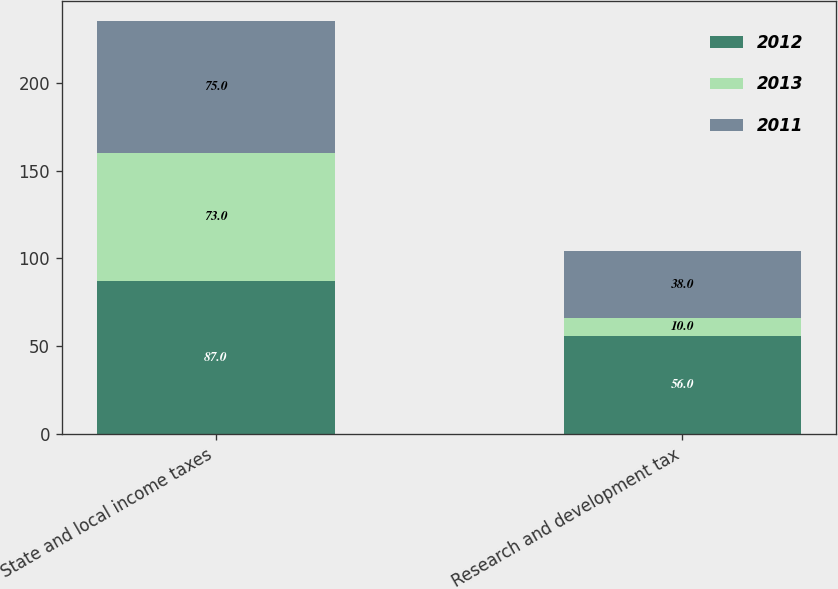Convert chart to OTSL. <chart><loc_0><loc_0><loc_500><loc_500><stacked_bar_chart><ecel><fcel>State and local income taxes<fcel>Research and development tax<nl><fcel>2012<fcel>87<fcel>56<nl><fcel>2013<fcel>73<fcel>10<nl><fcel>2011<fcel>75<fcel>38<nl></chart> 